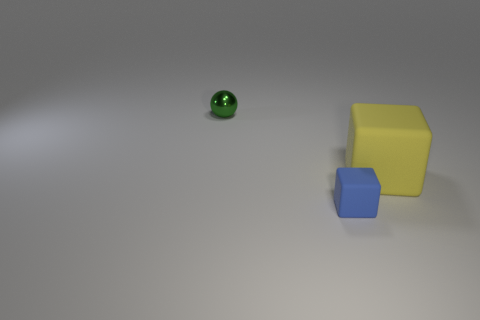Add 3 blue cubes. How many objects exist? 6 Subtract all balls. How many objects are left? 2 Add 2 small gray cubes. How many small gray cubes exist? 2 Subtract 0 red balls. How many objects are left? 3 Subtract 2 blocks. How many blocks are left? 0 Subtract all gray cubes. Subtract all purple cylinders. How many cubes are left? 2 Subtract all yellow blocks. How many purple balls are left? 0 Subtract all tiny blocks. Subtract all small purple cylinders. How many objects are left? 2 Add 3 tiny blocks. How many tiny blocks are left? 4 